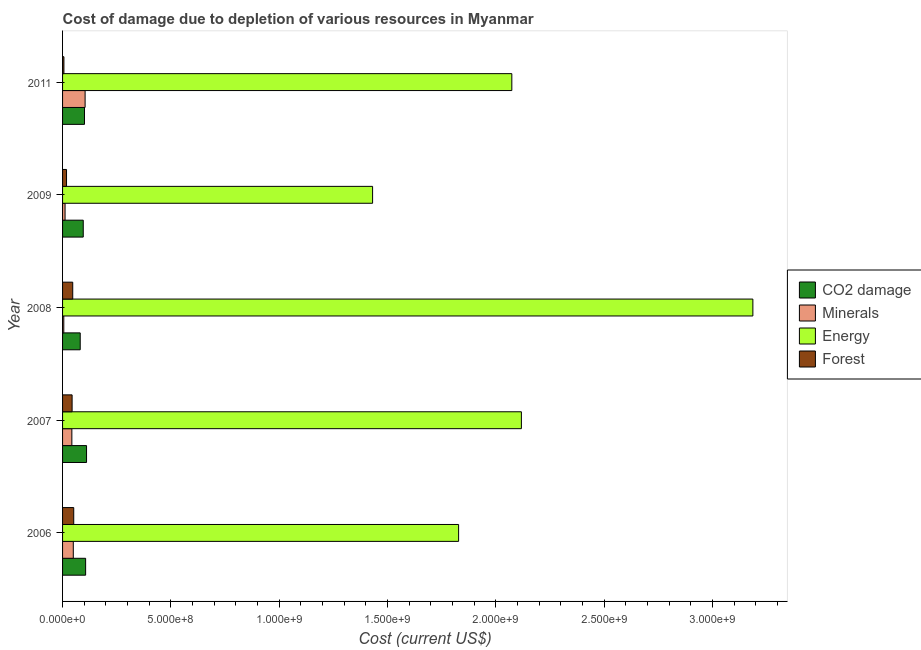How many groups of bars are there?
Provide a succinct answer. 5. Are the number of bars per tick equal to the number of legend labels?
Offer a very short reply. Yes. Are the number of bars on each tick of the Y-axis equal?
Your answer should be compact. Yes. How many bars are there on the 1st tick from the bottom?
Provide a short and direct response. 4. What is the label of the 2nd group of bars from the top?
Provide a succinct answer. 2009. What is the cost of damage due to depletion of energy in 2011?
Provide a succinct answer. 2.07e+09. Across all years, what is the maximum cost of damage due to depletion of coal?
Make the answer very short. 1.11e+08. Across all years, what is the minimum cost of damage due to depletion of forests?
Offer a very short reply. 6.26e+06. What is the total cost of damage due to depletion of coal in the graph?
Provide a succinct answer. 4.95e+08. What is the difference between the cost of damage due to depletion of minerals in 2006 and that in 2009?
Your response must be concise. 3.80e+07. What is the difference between the cost of damage due to depletion of energy in 2008 and the cost of damage due to depletion of forests in 2006?
Provide a succinct answer. 3.13e+09. What is the average cost of damage due to depletion of minerals per year?
Keep it short and to the point. 4.27e+07. In the year 2007, what is the difference between the cost of damage due to depletion of energy and cost of damage due to depletion of forests?
Your answer should be compact. 2.07e+09. What is the ratio of the cost of damage due to depletion of minerals in 2008 to that in 2011?
Offer a terse response. 0.06. Is the cost of damage due to depletion of energy in 2007 less than that in 2011?
Provide a succinct answer. No. Is the difference between the cost of damage due to depletion of forests in 2006 and 2008 greater than the difference between the cost of damage due to depletion of minerals in 2006 and 2008?
Offer a very short reply. No. What is the difference between the highest and the second highest cost of damage due to depletion of energy?
Offer a very short reply. 1.07e+09. What is the difference between the highest and the lowest cost of damage due to depletion of energy?
Provide a succinct answer. 1.76e+09. What does the 4th bar from the top in 2007 represents?
Provide a succinct answer. CO2 damage. What does the 3rd bar from the bottom in 2007 represents?
Offer a very short reply. Energy. Is it the case that in every year, the sum of the cost of damage due to depletion of coal and cost of damage due to depletion of minerals is greater than the cost of damage due to depletion of energy?
Offer a terse response. No. Are all the bars in the graph horizontal?
Your response must be concise. Yes. How many years are there in the graph?
Make the answer very short. 5. Does the graph contain any zero values?
Provide a succinct answer. No. Where does the legend appear in the graph?
Make the answer very short. Center right. How many legend labels are there?
Make the answer very short. 4. How are the legend labels stacked?
Your answer should be compact. Vertical. What is the title of the graph?
Offer a terse response. Cost of damage due to depletion of various resources in Myanmar . Does "Argument" appear as one of the legend labels in the graph?
Keep it short and to the point. No. What is the label or title of the X-axis?
Provide a succinct answer. Cost (current US$). What is the Cost (current US$) in CO2 damage in 2006?
Offer a terse response. 1.06e+08. What is the Cost (current US$) of Minerals in 2006?
Provide a short and direct response. 4.95e+07. What is the Cost (current US$) of Energy in 2006?
Make the answer very short. 1.83e+09. What is the Cost (current US$) in Forest in 2006?
Ensure brevity in your answer.  5.15e+07. What is the Cost (current US$) in CO2 damage in 2007?
Provide a succinct answer. 1.11e+08. What is the Cost (current US$) of Minerals in 2007?
Your answer should be very brief. 4.29e+07. What is the Cost (current US$) of Energy in 2007?
Give a very brief answer. 2.12e+09. What is the Cost (current US$) of Forest in 2007?
Offer a very short reply. 4.40e+07. What is the Cost (current US$) of CO2 damage in 2008?
Give a very brief answer. 8.15e+07. What is the Cost (current US$) of Minerals in 2008?
Your answer should be compact. 5.68e+06. What is the Cost (current US$) of Energy in 2008?
Provide a succinct answer. 3.19e+09. What is the Cost (current US$) of Forest in 2008?
Your response must be concise. 4.70e+07. What is the Cost (current US$) of CO2 damage in 2009?
Offer a very short reply. 9.55e+07. What is the Cost (current US$) of Minerals in 2009?
Make the answer very short. 1.15e+07. What is the Cost (current US$) in Energy in 2009?
Your answer should be compact. 1.43e+09. What is the Cost (current US$) in Forest in 2009?
Your answer should be very brief. 1.83e+07. What is the Cost (current US$) in CO2 damage in 2011?
Provide a short and direct response. 1.01e+08. What is the Cost (current US$) of Minerals in 2011?
Make the answer very short. 1.04e+08. What is the Cost (current US$) in Energy in 2011?
Your response must be concise. 2.07e+09. What is the Cost (current US$) in Forest in 2011?
Your response must be concise. 6.26e+06. Across all years, what is the maximum Cost (current US$) in CO2 damage?
Your response must be concise. 1.11e+08. Across all years, what is the maximum Cost (current US$) in Minerals?
Offer a terse response. 1.04e+08. Across all years, what is the maximum Cost (current US$) of Energy?
Provide a succinct answer. 3.19e+09. Across all years, what is the maximum Cost (current US$) in Forest?
Your response must be concise. 5.15e+07. Across all years, what is the minimum Cost (current US$) in CO2 damage?
Your answer should be very brief. 8.15e+07. Across all years, what is the minimum Cost (current US$) of Minerals?
Your answer should be very brief. 5.68e+06. Across all years, what is the minimum Cost (current US$) in Energy?
Keep it short and to the point. 1.43e+09. Across all years, what is the minimum Cost (current US$) in Forest?
Offer a very short reply. 6.26e+06. What is the total Cost (current US$) in CO2 damage in the graph?
Your response must be concise. 4.95e+08. What is the total Cost (current US$) in Minerals in the graph?
Provide a short and direct response. 2.14e+08. What is the total Cost (current US$) of Energy in the graph?
Provide a short and direct response. 1.06e+1. What is the total Cost (current US$) of Forest in the graph?
Your response must be concise. 1.67e+08. What is the difference between the Cost (current US$) in CO2 damage in 2006 and that in 2007?
Your answer should be compact. -4.21e+06. What is the difference between the Cost (current US$) in Minerals in 2006 and that in 2007?
Your response must be concise. 6.64e+06. What is the difference between the Cost (current US$) in Energy in 2006 and that in 2007?
Provide a succinct answer. -2.90e+08. What is the difference between the Cost (current US$) of Forest in 2006 and that in 2007?
Give a very brief answer. 7.51e+06. What is the difference between the Cost (current US$) in CO2 damage in 2006 and that in 2008?
Offer a terse response. 2.50e+07. What is the difference between the Cost (current US$) of Minerals in 2006 and that in 2008?
Offer a very short reply. 4.39e+07. What is the difference between the Cost (current US$) of Energy in 2006 and that in 2008?
Give a very brief answer. -1.36e+09. What is the difference between the Cost (current US$) of Forest in 2006 and that in 2008?
Provide a succinct answer. 4.57e+06. What is the difference between the Cost (current US$) in CO2 damage in 2006 and that in 2009?
Your answer should be very brief. 1.10e+07. What is the difference between the Cost (current US$) of Minerals in 2006 and that in 2009?
Offer a very short reply. 3.80e+07. What is the difference between the Cost (current US$) of Energy in 2006 and that in 2009?
Offer a very short reply. 3.97e+08. What is the difference between the Cost (current US$) in Forest in 2006 and that in 2009?
Give a very brief answer. 3.32e+07. What is the difference between the Cost (current US$) in CO2 damage in 2006 and that in 2011?
Provide a succinct answer. 5.27e+06. What is the difference between the Cost (current US$) of Minerals in 2006 and that in 2011?
Your response must be concise. -5.45e+07. What is the difference between the Cost (current US$) in Energy in 2006 and that in 2011?
Make the answer very short. -2.46e+08. What is the difference between the Cost (current US$) of Forest in 2006 and that in 2011?
Your answer should be very brief. 4.53e+07. What is the difference between the Cost (current US$) in CO2 damage in 2007 and that in 2008?
Offer a very short reply. 2.92e+07. What is the difference between the Cost (current US$) of Minerals in 2007 and that in 2008?
Offer a terse response. 3.72e+07. What is the difference between the Cost (current US$) in Energy in 2007 and that in 2008?
Provide a short and direct response. -1.07e+09. What is the difference between the Cost (current US$) of Forest in 2007 and that in 2008?
Give a very brief answer. -2.94e+06. What is the difference between the Cost (current US$) in CO2 damage in 2007 and that in 2009?
Provide a succinct answer. 1.52e+07. What is the difference between the Cost (current US$) in Minerals in 2007 and that in 2009?
Ensure brevity in your answer.  3.14e+07. What is the difference between the Cost (current US$) of Energy in 2007 and that in 2009?
Ensure brevity in your answer.  6.87e+08. What is the difference between the Cost (current US$) in Forest in 2007 and that in 2009?
Provide a short and direct response. 2.57e+07. What is the difference between the Cost (current US$) of CO2 damage in 2007 and that in 2011?
Your answer should be compact. 9.48e+06. What is the difference between the Cost (current US$) of Minerals in 2007 and that in 2011?
Offer a very short reply. -6.11e+07. What is the difference between the Cost (current US$) of Energy in 2007 and that in 2011?
Your response must be concise. 4.41e+07. What is the difference between the Cost (current US$) of Forest in 2007 and that in 2011?
Your response must be concise. 3.78e+07. What is the difference between the Cost (current US$) of CO2 damage in 2008 and that in 2009?
Offer a terse response. -1.40e+07. What is the difference between the Cost (current US$) of Minerals in 2008 and that in 2009?
Ensure brevity in your answer.  -5.85e+06. What is the difference between the Cost (current US$) in Energy in 2008 and that in 2009?
Provide a short and direct response. 1.76e+09. What is the difference between the Cost (current US$) in Forest in 2008 and that in 2009?
Provide a succinct answer. 2.86e+07. What is the difference between the Cost (current US$) in CO2 damage in 2008 and that in 2011?
Make the answer very short. -1.97e+07. What is the difference between the Cost (current US$) of Minerals in 2008 and that in 2011?
Make the answer very short. -9.83e+07. What is the difference between the Cost (current US$) of Energy in 2008 and that in 2011?
Ensure brevity in your answer.  1.11e+09. What is the difference between the Cost (current US$) in Forest in 2008 and that in 2011?
Make the answer very short. 4.07e+07. What is the difference between the Cost (current US$) of CO2 damage in 2009 and that in 2011?
Your answer should be very brief. -5.74e+06. What is the difference between the Cost (current US$) of Minerals in 2009 and that in 2011?
Keep it short and to the point. -9.25e+07. What is the difference between the Cost (current US$) of Energy in 2009 and that in 2011?
Offer a terse response. -6.43e+08. What is the difference between the Cost (current US$) in Forest in 2009 and that in 2011?
Offer a terse response. 1.21e+07. What is the difference between the Cost (current US$) in CO2 damage in 2006 and the Cost (current US$) in Minerals in 2007?
Offer a very short reply. 6.36e+07. What is the difference between the Cost (current US$) of CO2 damage in 2006 and the Cost (current US$) of Energy in 2007?
Keep it short and to the point. -2.01e+09. What is the difference between the Cost (current US$) in CO2 damage in 2006 and the Cost (current US$) in Forest in 2007?
Ensure brevity in your answer.  6.24e+07. What is the difference between the Cost (current US$) in Minerals in 2006 and the Cost (current US$) in Energy in 2007?
Your answer should be very brief. -2.07e+09. What is the difference between the Cost (current US$) of Minerals in 2006 and the Cost (current US$) of Forest in 2007?
Provide a short and direct response. 5.51e+06. What is the difference between the Cost (current US$) of Energy in 2006 and the Cost (current US$) of Forest in 2007?
Make the answer very short. 1.78e+09. What is the difference between the Cost (current US$) in CO2 damage in 2006 and the Cost (current US$) in Minerals in 2008?
Provide a succinct answer. 1.01e+08. What is the difference between the Cost (current US$) in CO2 damage in 2006 and the Cost (current US$) in Energy in 2008?
Make the answer very short. -3.08e+09. What is the difference between the Cost (current US$) of CO2 damage in 2006 and the Cost (current US$) of Forest in 2008?
Offer a very short reply. 5.95e+07. What is the difference between the Cost (current US$) in Minerals in 2006 and the Cost (current US$) in Energy in 2008?
Offer a terse response. -3.14e+09. What is the difference between the Cost (current US$) of Minerals in 2006 and the Cost (current US$) of Forest in 2008?
Provide a short and direct response. 2.57e+06. What is the difference between the Cost (current US$) in Energy in 2006 and the Cost (current US$) in Forest in 2008?
Provide a short and direct response. 1.78e+09. What is the difference between the Cost (current US$) in CO2 damage in 2006 and the Cost (current US$) in Minerals in 2009?
Offer a very short reply. 9.49e+07. What is the difference between the Cost (current US$) in CO2 damage in 2006 and the Cost (current US$) in Energy in 2009?
Offer a very short reply. -1.32e+09. What is the difference between the Cost (current US$) in CO2 damage in 2006 and the Cost (current US$) in Forest in 2009?
Make the answer very short. 8.81e+07. What is the difference between the Cost (current US$) of Minerals in 2006 and the Cost (current US$) of Energy in 2009?
Your answer should be very brief. -1.38e+09. What is the difference between the Cost (current US$) of Minerals in 2006 and the Cost (current US$) of Forest in 2009?
Your response must be concise. 3.12e+07. What is the difference between the Cost (current US$) of Energy in 2006 and the Cost (current US$) of Forest in 2009?
Offer a terse response. 1.81e+09. What is the difference between the Cost (current US$) of CO2 damage in 2006 and the Cost (current US$) of Minerals in 2011?
Keep it short and to the point. 2.44e+06. What is the difference between the Cost (current US$) in CO2 damage in 2006 and the Cost (current US$) in Energy in 2011?
Give a very brief answer. -1.97e+09. What is the difference between the Cost (current US$) in CO2 damage in 2006 and the Cost (current US$) in Forest in 2011?
Make the answer very short. 1.00e+08. What is the difference between the Cost (current US$) of Minerals in 2006 and the Cost (current US$) of Energy in 2011?
Give a very brief answer. -2.02e+09. What is the difference between the Cost (current US$) in Minerals in 2006 and the Cost (current US$) in Forest in 2011?
Provide a succinct answer. 4.33e+07. What is the difference between the Cost (current US$) in Energy in 2006 and the Cost (current US$) in Forest in 2011?
Offer a terse response. 1.82e+09. What is the difference between the Cost (current US$) of CO2 damage in 2007 and the Cost (current US$) of Minerals in 2008?
Your response must be concise. 1.05e+08. What is the difference between the Cost (current US$) of CO2 damage in 2007 and the Cost (current US$) of Energy in 2008?
Make the answer very short. -3.08e+09. What is the difference between the Cost (current US$) of CO2 damage in 2007 and the Cost (current US$) of Forest in 2008?
Provide a succinct answer. 6.37e+07. What is the difference between the Cost (current US$) in Minerals in 2007 and the Cost (current US$) in Energy in 2008?
Keep it short and to the point. -3.14e+09. What is the difference between the Cost (current US$) in Minerals in 2007 and the Cost (current US$) in Forest in 2008?
Provide a short and direct response. -4.07e+06. What is the difference between the Cost (current US$) in Energy in 2007 and the Cost (current US$) in Forest in 2008?
Your response must be concise. 2.07e+09. What is the difference between the Cost (current US$) in CO2 damage in 2007 and the Cost (current US$) in Minerals in 2009?
Provide a succinct answer. 9.91e+07. What is the difference between the Cost (current US$) of CO2 damage in 2007 and the Cost (current US$) of Energy in 2009?
Provide a short and direct response. -1.32e+09. What is the difference between the Cost (current US$) of CO2 damage in 2007 and the Cost (current US$) of Forest in 2009?
Provide a succinct answer. 9.23e+07. What is the difference between the Cost (current US$) in Minerals in 2007 and the Cost (current US$) in Energy in 2009?
Offer a terse response. -1.39e+09. What is the difference between the Cost (current US$) in Minerals in 2007 and the Cost (current US$) in Forest in 2009?
Offer a very short reply. 2.46e+07. What is the difference between the Cost (current US$) of Energy in 2007 and the Cost (current US$) of Forest in 2009?
Give a very brief answer. 2.10e+09. What is the difference between the Cost (current US$) of CO2 damage in 2007 and the Cost (current US$) of Minerals in 2011?
Offer a very short reply. 6.65e+06. What is the difference between the Cost (current US$) of CO2 damage in 2007 and the Cost (current US$) of Energy in 2011?
Make the answer very short. -1.96e+09. What is the difference between the Cost (current US$) of CO2 damage in 2007 and the Cost (current US$) of Forest in 2011?
Provide a succinct answer. 1.04e+08. What is the difference between the Cost (current US$) in Minerals in 2007 and the Cost (current US$) in Energy in 2011?
Keep it short and to the point. -2.03e+09. What is the difference between the Cost (current US$) of Minerals in 2007 and the Cost (current US$) of Forest in 2011?
Give a very brief answer. 3.66e+07. What is the difference between the Cost (current US$) in Energy in 2007 and the Cost (current US$) in Forest in 2011?
Offer a terse response. 2.11e+09. What is the difference between the Cost (current US$) of CO2 damage in 2008 and the Cost (current US$) of Minerals in 2009?
Provide a succinct answer. 6.99e+07. What is the difference between the Cost (current US$) in CO2 damage in 2008 and the Cost (current US$) in Energy in 2009?
Your response must be concise. -1.35e+09. What is the difference between the Cost (current US$) of CO2 damage in 2008 and the Cost (current US$) of Forest in 2009?
Make the answer very short. 6.31e+07. What is the difference between the Cost (current US$) in Minerals in 2008 and the Cost (current US$) in Energy in 2009?
Ensure brevity in your answer.  -1.43e+09. What is the difference between the Cost (current US$) in Minerals in 2008 and the Cost (current US$) in Forest in 2009?
Provide a short and direct response. -1.27e+07. What is the difference between the Cost (current US$) of Energy in 2008 and the Cost (current US$) of Forest in 2009?
Offer a terse response. 3.17e+09. What is the difference between the Cost (current US$) in CO2 damage in 2008 and the Cost (current US$) in Minerals in 2011?
Your response must be concise. -2.26e+07. What is the difference between the Cost (current US$) of CO2 damage in 2008 and the Cost (current US$) of Energy in 2011?
Offer a terse response. -1.99e+09. What is the difference between the Cost (current US$) in CO2 damage in 2008 and the Cost (current US$) in Forest in 2011?
Provide a short and direct response. 7.52e+07. What is the difference between the Cost (current US$) of Minerals in 2008 and the Cost (current US$) of Energy in 2011?
Ensure brevity in your answer.  -2.07e+09. What is the difference between the Cost (current US$) in Minerals in 2008 and the Cost (current US$) in Forest in 2011?
Provide a short and direct response. -5.76e+05. What is the difference between the Cost (current US$) of Energy in 2008 and the Cost (current US$) of Forest in 2011?
Give a very brief answer. 3.18e+09. What is the difference between the Cost (current US$) in CO2 damage in 2009 and the Cost (current US$) in Minerals in 2011?
Give a very brief answer. -8.57e+06. What is the difference between the Cost (current US$) in CO2 damage in 2009 and the Cost (current US$) in Energy in 2011?
Ensure brevity in your answer.  -1.98e+09. What is the difference between the Cost (current US$) in CO2 damage in 2009 and the Cost (current US$) in Forest in 2011?
Provide a succinct answer. 8.92e+07. What is the difference between the Cost (current US$) of Minerals in 2009 and the Cost (current US$) of Energy in 2011?
Your answer should be compact. -2.06e+09. What is the difference between the Cost (current US$) of Minerals in 2009 and the Cost (current US$) of Forest in 2011?
Your answer should be compact. 5.27e+06. What is the difference between the Cost (current US$) of Energy in 2009 and the Cost (current US$) of Forest in 2011?
Give a very brief answer. 1.42e+09. What is the average Cost (current US$) in CO2 damage per year?
Your answer should be very brief. 9.90e+07. What is the average Cost (current US$) in Minerals per year?
Offer a very short reply. 4.27e+07. What is the average Cost (current US$) in Energy per year?
Offer a terse response. 2.13e+09. What is the average Cost (current US$) in Forest per year?
Ensure brevity in your answer.  3.34e+07. In the year 2006, what is the difference between the Cost (current US$) in CO2 damage and Cost (current US$) in Minerals?
Offer a terse response. 5.69e+07. In the year 2006, what is the difference between the Cost (current US$) of CO2 damage and Cost (current US$) of Energy?
Keep it short and to the point. -1.72e+09. In the year 2006, what is the difference between the Cost (current US$) in CO2 damage and Cost (current US$) in Forest?
Provide a short and direct response. 5.49e+07. In the year 2006, what is the difference between the Cost (current US$) of Minerals and Cost (current US$) of Energy?
Ensure brevity in your answer.  -1.78e+09. In the year 2006, what is the difference between the Cost (current US$) in Minerals and Cost (current US$) in Forest?
Provide a succinct answer. -2.00e+06. In the year 2006, what is the difference between the Cost (current US$) in Energy and Cost (current US$) in Forest?
Your answer should be very brief. 1.78e+09. In the year 2007, what is the difference between the Cost (current US$) of CO2 damage and Cost (current US$) of Minerals?
Your answer should be very brief. 6.78e+07. In the year 2007, what is the difference between the Cost (current US$) in CO2 damage and Cost (current US$) in Energy?
Your answer should be compact. -2.01e+09. In the year 2007, what is the difference between the Cost (current US$) of CO2 damage and Cost (current US$) of Forest?
Offer a terse response. 6.66e+07. In the year 2007, what is the difference between the Cost (current US$) in Minerals and Cost (current US$) in Energy?
Your response must be concise. -2.07e+09. In the year 2007, what is the difference between the Cost (current US$) of Minerals and Cost (current US$) of Forest?
Make the answer very short. -1.13e+06. In the year 2007, what is the difference between the Cost (current US$) of Energy and Cost (current US$) of Forest?
Keep it short and to the point. 2.07e+09. In the year 2008, what is the difference between the Cost (current US$) in CO2 damage and Cost (current US$) in Minerals?
Give a very brief answer. 7.58e+07. In the year 2008, what is the difference between the Cost (current US$) of CO2 damage and Cost (current US$) of Energy?
Your response must be concise. -3.10e+09. In the year 2008, what is the difference between the Cost (current US$) in CO2 damage and Cost (current US$) in Forest?
Offer a terse response. 3.45e+07. In the year 2008, what is the difference between the Cost (current US$) in Minerals and Cost (current US$) in Energy?
Provide a succinct answer. -3.18e+09. In the year 2008, what is the difference between the Cost (current US$) of Minerals and Cost (current US$) of Forest?
Give a very brief answer. -4.13e+07. In the year 2008, what is the difference between the Cost (current US$) in Energy and Cost (current US$) in Forest?
Give a very brief answer. 3.14e+09. In the year 2009, what is the difference between the Cost (current US$) in CO2 damage and Cost (current US$) in Minerals?
Give a very brief answer. 8.39e+07. In the year 2009, what is the difference between the Cost (current US$) in CO2 damage and Cost (current US$) in Energy?
Offer a very short reply. -1.34e+09. In the year 2009, what is the difference between the Cost (current US$) of CO2 damage and Cost (current US$) of Forest?
Give a very brief answer. 7.71e+07. In the year 2009, what is the difference between the Cost (current US$) in Minerals and Cost (current US$) in Energy?
Your answer should be very brief. -1.42e+09. In the year 2009, what is the difference between the Cost (current US$) in Minerals and Cost (current US$) in Forest?
Make the answer very short. -6.80e+06. In the year 2009, what is the difference between the Cost (current US$) of Energy and Cost (current US$) of Forest?
Offer a very short reply. 1.41e+09. In the year 2011, what is the difference between the Cost (current US$) in CO2 damage and Cost (current US$) in Minerals?
Your answer should be compact. -2.83e+06. In the year 2011, what is the difference between the Cost (current US$) of CO2 damage and Cost (current US$) of Energy?
Offer a very short reply. -1.97e+09. In the year 2011, what is the difference between the Cost (current US$) of CO2 damage and Cost (current US$) of Forest?
Offer a terse response. 9.49e+07. In the year 2011, what is the difference between the Cost (current US$) in Minerals and Cost (current US$) in Energy?
Your answer should be very brief. -1.97e+09. In the year 2011, what is the difference between the Cost (current US$) in Minerals and Cost (current US$) in Forest?
Provide a short and direct response. 9.78e+07. In the year 2011, what is the difference between the Cost (current US$) of Energy and Cost (current US$) of Forest?
Your answer should be compact. 2.07e+09. What is the ratio of the Cost (current US$) of CO2 damage in 2006 to that in 2007?
Provide a succinct answer. 0.96. What is the ratio of the Cost (current US$) in Minerals in 2006 to that in 2007?
Keep it short and to the point. 1.15. What is the ratio of the Cost (current US$) in Energy in 2006 to that in 2007?
Give a very brief answer. 0.86. What is the ratio of the Cost (current US$) of Forest in 2006 to that in 2007?
Offer a terse response. 1.17. What is the ratio of the Cost (current US$) of CO2 damage in 2006 to that in 2008?
Give a very brief answer. 1.31. What is the ratio of the Cost (current US$) in Minerals in 2006 to that in 2008?
Your answer should be compact. 8.72. What is the ratio of the Cost (current US$) of Energy in 2006 to that in 2008?
Make the answer very short. 0.57. What is the ratio of the Cost (current US$) in Forest in 2006 to that in 2008?
Provide a short and direct response. 1.1. What is the ratio of the Cost (current US$) in CO2 damage in 2006 to that in 2009?
Your response must be concise. 1.12. What is the ratio of the Cost (current US$) in Minerals in 2006 to that in 2009?
Offer a terse response. 4.3. What is the ratio of the Cost (current US$) of Energy in 2006 to that in 2009?
Your answer should be compact. 1.28. What is the ratio of the Cost (current US$) in Forest in 2006 to that in 2009?
Your response must be concise. 2.81. What is the ratio of the Cost (current US$) of CO2 damage in 2006 to that in 2011?
Give a very brief answer. 1.05. What is the ratio of the Cost (current US$) in Minerals in 2006 to that in 2011?
Give a very brief answer. 0.48. What is the ratio of the Cost (current US$) in Energy in 2006 to that in 2011?
Your answer should be compact. 0.88. What is the ratio of the Cost (current US$) in Forest in 2006 to that in 2011?
Keep it short and to the point. 8.23. What is the ratio of the Cost (current US$) in CO2 damage in 2007 to that in 2008?
Ensure brevity in your answer.  1.36. What is the ratio of the Cost (current US$) of Minerals in 2007 to that in 2008?
Give a very brief answer. 7.55. What is the ratio of the Cost (current US$) in Energy in 2007 to that in 2008?
Your answer should be very brief. 0.66. What is the ratio of the Cost (current US$) in Forest in 2007 to that in 2008?
Your answer should be very brief. 0.94. What is the ratio of the Cost (current US$) of CO2 damage in 2007 to that in 2009?
Provide a succinct answer. 1.16. What is the ratio of the Cost (current US$) of Minerals in 2007 to that in 2009?
Your answer should be very brief. 3.72. What is the ratio of the Cost (current US$) of Energy in 2007 to that in 2009?
Ensure brevity in your answer.  1.48. What is the ratio of the Cost (current US$) in Forest in 2007 to that in 2009?
Keep it short and to the point. 2.4. What is the ratio of the Cost (current US$) in CO2 damage in 2007 to that in 2011?
Keep it short and to the point. 1.09. What is the ratio of the Cost (current US$) in Minerals in 2007 to that in 2011?
Give a very brief answer. 0.41. What is the ratio of the Cost (current US$) of Energy in 2007 to that in 2011?
Offer a terse response. 1.02. What is the ratio of the Cost (current US$) of Forest in 2007 to that in 2011?
Your answer should be compact. 7.04. What is the ratio of the Cost (current US$) in CO2 damage in 2008 to that in 2009?
Offer a terse response. 0.85. What is the ratio of the Cost (current US$) in Minerals in 2008 to that in 2009?
Ensure brevity in your answer.  0.49. What is the ratio of the Cost (current US$) of Energy in 2008 to that in 2009?
Offer a terse response. 2.23. What is the ratio of the Cost (current US$) of Forest in 2008 to that in 2009?
Offer a very short reply. 2.56. What is the ratio of the Cost (current US$) in CO2 damage in 2008 to that in 2011?
Offer a very short reply. 0.81. What is the ratio of the Cost (current US$) of Minerals in 2008 to that in 2011?
Give a very brief answer. 0.05. What is the ratio of the Cost (current US$) of Energy in 2008 to that in 2011?
Keep it short and to the point. 1.54. What is the ratio of the Cost (current US$) of Forest in 2008 to that in 2011?
Your response must be concise. 7.51. What is the ratio of the Cost (current US$) in CO2 damage in 2009 to that in 2011?
Your response must be concise. 0.94. What is the ratio of the Cost (current US$) of Minerals in 2009 to that in 2011?
Provide a succinct answer. 0.11. What is the ratio of the Cost (current US$) in Energy in 2009 to that in 2011?
Your answer should be compact. 0.69. What is the ratio of the Cost (current US$) in Forest in 2009 to that in 2011?
Provide a short and direct response. 2.93. What is the difference between the highest and the second highest Cost (current US$) of CO2 damage?
Keep it short and to the point. 4.21e+06. What is the difference between the highest and the second highest Cost (current US$) of Minerals?
Your response must be concise. 5.45e+07. What is the difference between the highest and the second highest Cost (current US$) in Energy?
Ensure brevity in your answer.  1.07e+09. What is the difference between the highest and the second highest Cost (current US$) in Forest?
Keep it short and to the point. 4.57e+06. What is the difference between the highest and the lowest Cost (current US$) of CO2 damage?
Provide a short and direct response. 2.92e+07. What is the difference between the highest and the lowest Cost (current US$) of Minerals?
Your answer should be very brief. 9.83e+07. What is the difference between the highest and the lowest Cost (current US$) of Energy?
Your answer should be very brief. 1.76e+09. What is the difference between the highest and the lowest Cost (current US$) of Forest?
Ensure brevity in your answer.  4.53e+07. 